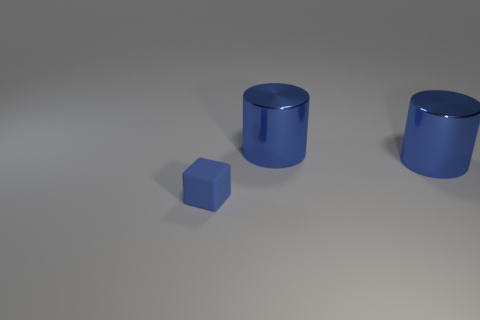How many blue cylinders must be subtracted to get 1 blue cylinders? 1 Add 3 tiny objects. How many objects exist? 6 Subtract all blocks. How many objects are left? 2 Subtract all small rubber objects. Subtract all cyan things. How many objects are left? 2 Add 2 blue matte blocks. How many blue matte blocks are left? 3 Add 2 blue cylinders. How many blue cylinders exist? 4 Subtract 0 cyan spheres. How many objects are left? 3 